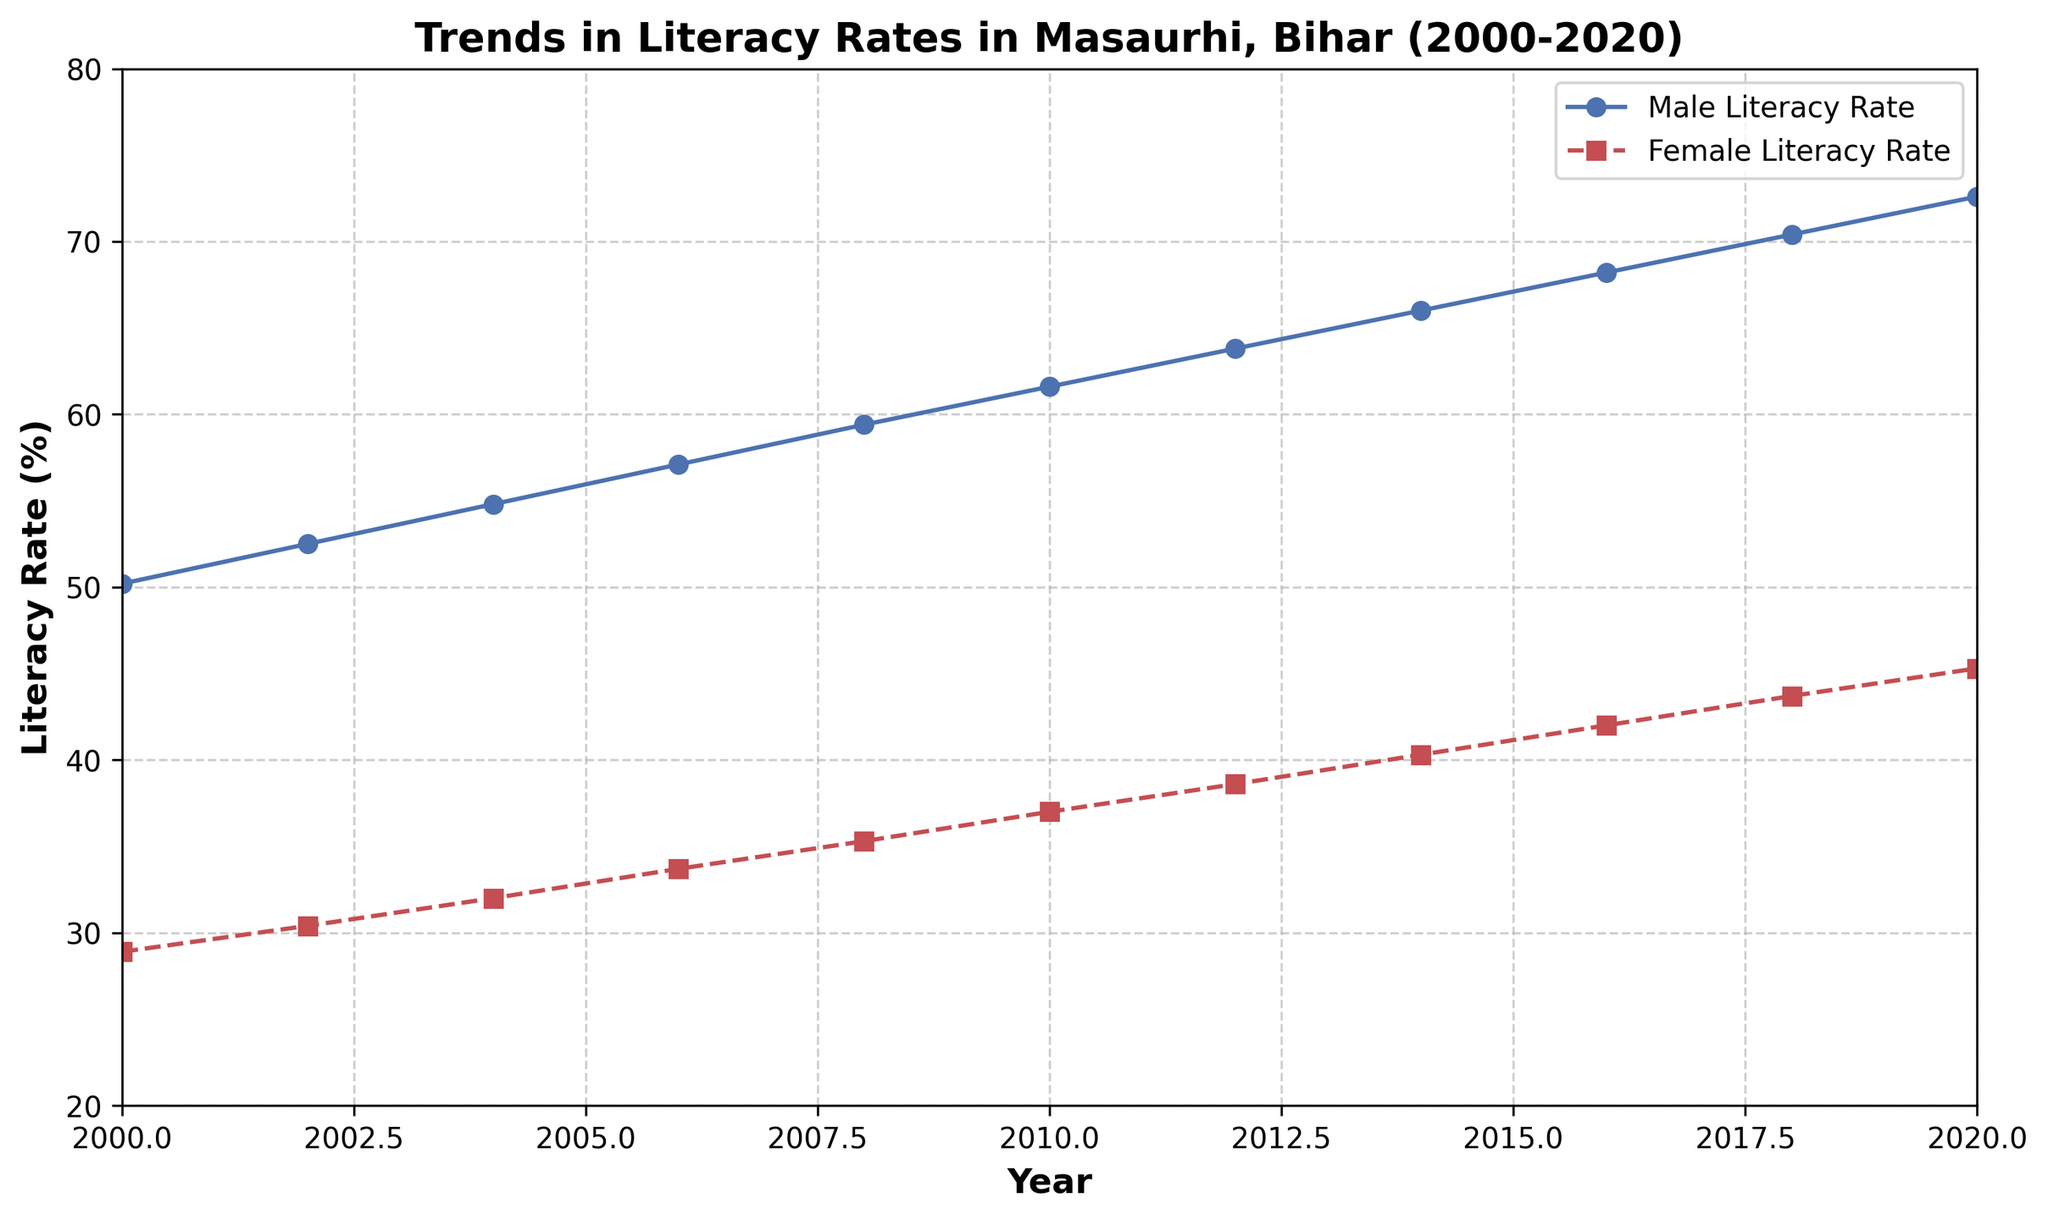What is the difference in the literacy rate of males between 2000 and 2020? In 2000, the male literacy rate was 50.2%, and in 2020, it was 72.6%. The difference is 72.6% - 50.2% = 22.4%.
Answer: 22.4% Which year showed the highest male literacy rate? The highest male literacy rate on the chart is 72.6% in the year 2020.
Answer: 2020 How much did the female literacy rate increase from 2000 to 2020? The female literacy rate in 2000 was 28.9%, and in 2020, it was 45.3%. The increase is 45.3% - 28.9% = 16.4%.
Answer: 16.4% In which year did the female literacy rate reach 40% or more for the first time? The female literacy rate reached 40% for the first time in the year 2014, as it was 40.3% in that year.
Answer: 2014 How does the literacy rate trend for both genders compare from 2000 to 2020? Both male and female literacy rates show an increasing trend from 2000 to 2020. Males consistently have a higher literacy rate than females over the entire period.
Answer: Increasing for both, males always higher What is the average female literacy rate from 2000 to 2020? The sum of the female literacy rates from 2000 to 2020 is 28.9 + 30.4 + 32.0 + 33.7 + 35.3 + 37.0 + 38.6 + 40.3 + 42.0 + 43.7 + 45.3 = 407.2. The number of years is 11, so the average is 407.2 / 11 = 37.02%.
Answer: 37.02% What is the rate of increase per year for the male literacy rate between 2000 and 2020? The male literacy rate increased from 50.2% in 2000 to 72.6% in 2020, a total increase of 22.4% over 20 years. The rate of increase per year is 22.4% / 20 years = 1.12%.
Answer: 1.12% per year Compare the gap between male and female literacy rates in 2000 and 2020. In 2000, the gap was 50.2% - 28.9% = 21.3%. In 2020, the gap was 72.6% - 45.3% = 27.3%. Therefore, the gap increased by 27.3% - 21.3% = 6%.
Answer: Increased by 6% By how much did the female literacy rate lag behind the male literacy rate in 2010? In 2010, the male literacy rate was 61.6%, and the female literacy rate was 37.0%. The lag is 61.6% - 37.0% = 24.6%.
Answer: 24.6% 